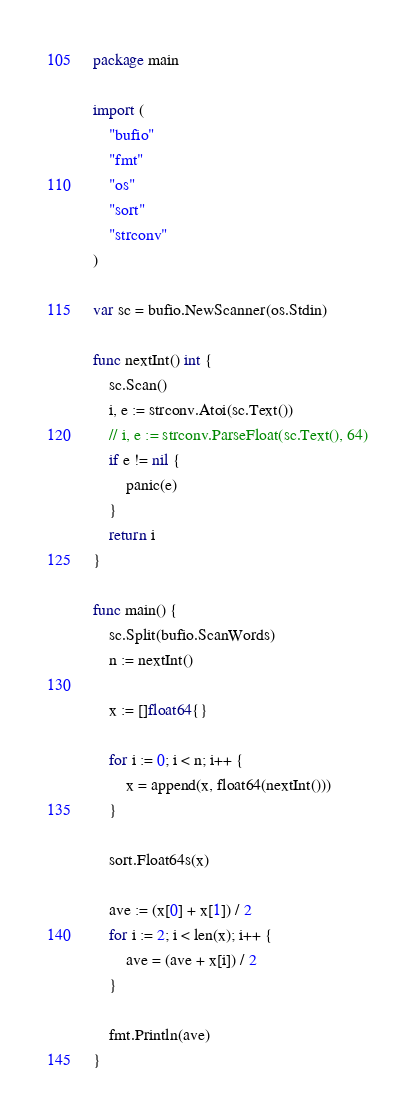<code> <loc_0><loc_0><loc_500><loc_500><_Go_>package main

import (
	"bufio"
	"fmt"
	"os"
	"sort"
	"strconv"
)

var sc = bufio.NewScanner(os.Stdin)

func nextInt() int {
	sc.Scan()
	i, e := strconv.Atoi(sc.Text())
	// i, e := strconv.ParseFloat(sc.Text(), 64)
	if e != nil {
		panic(e)
	}
	return i
}

func main() {
	sc.Split(bufio.ScanWords)
	n := nextInt()

	x := []float64{}

	for i := 0; i < n; i++ {
		x = append(x, float64(nextInt()))
	}

	sort.Float64s(x)

	ave := (x[0] + x[1]) / 2
	for i := 2; i < len(x); i++ {
		ave = (ave + x[i]) / 2
	}

	fmt.Println(ave)
}
</code> 